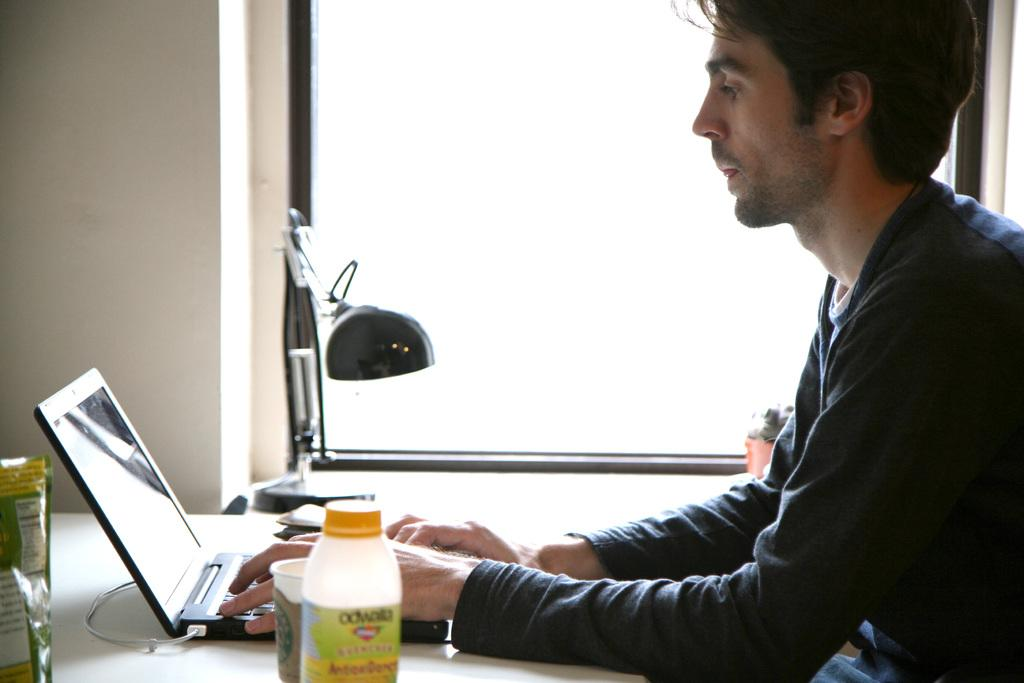Who is present in the image? There is a man in the image. What is the man doing in the image? The man is sitting on a chair. Where is the chair located in relation to the table? The chair is in front of a table. What electronic device is on the table? There is a laptop on the table. What is the purpose of the lamp on the table? The lamp provides light for the man to see while using the laptop. What other objects can be seen on the table? There are other objects on the table, but their specific details are not mentioned in the facts. What type of cable is the governor using to connect to the laptop in the image? There is no governor or cable present in the image. 